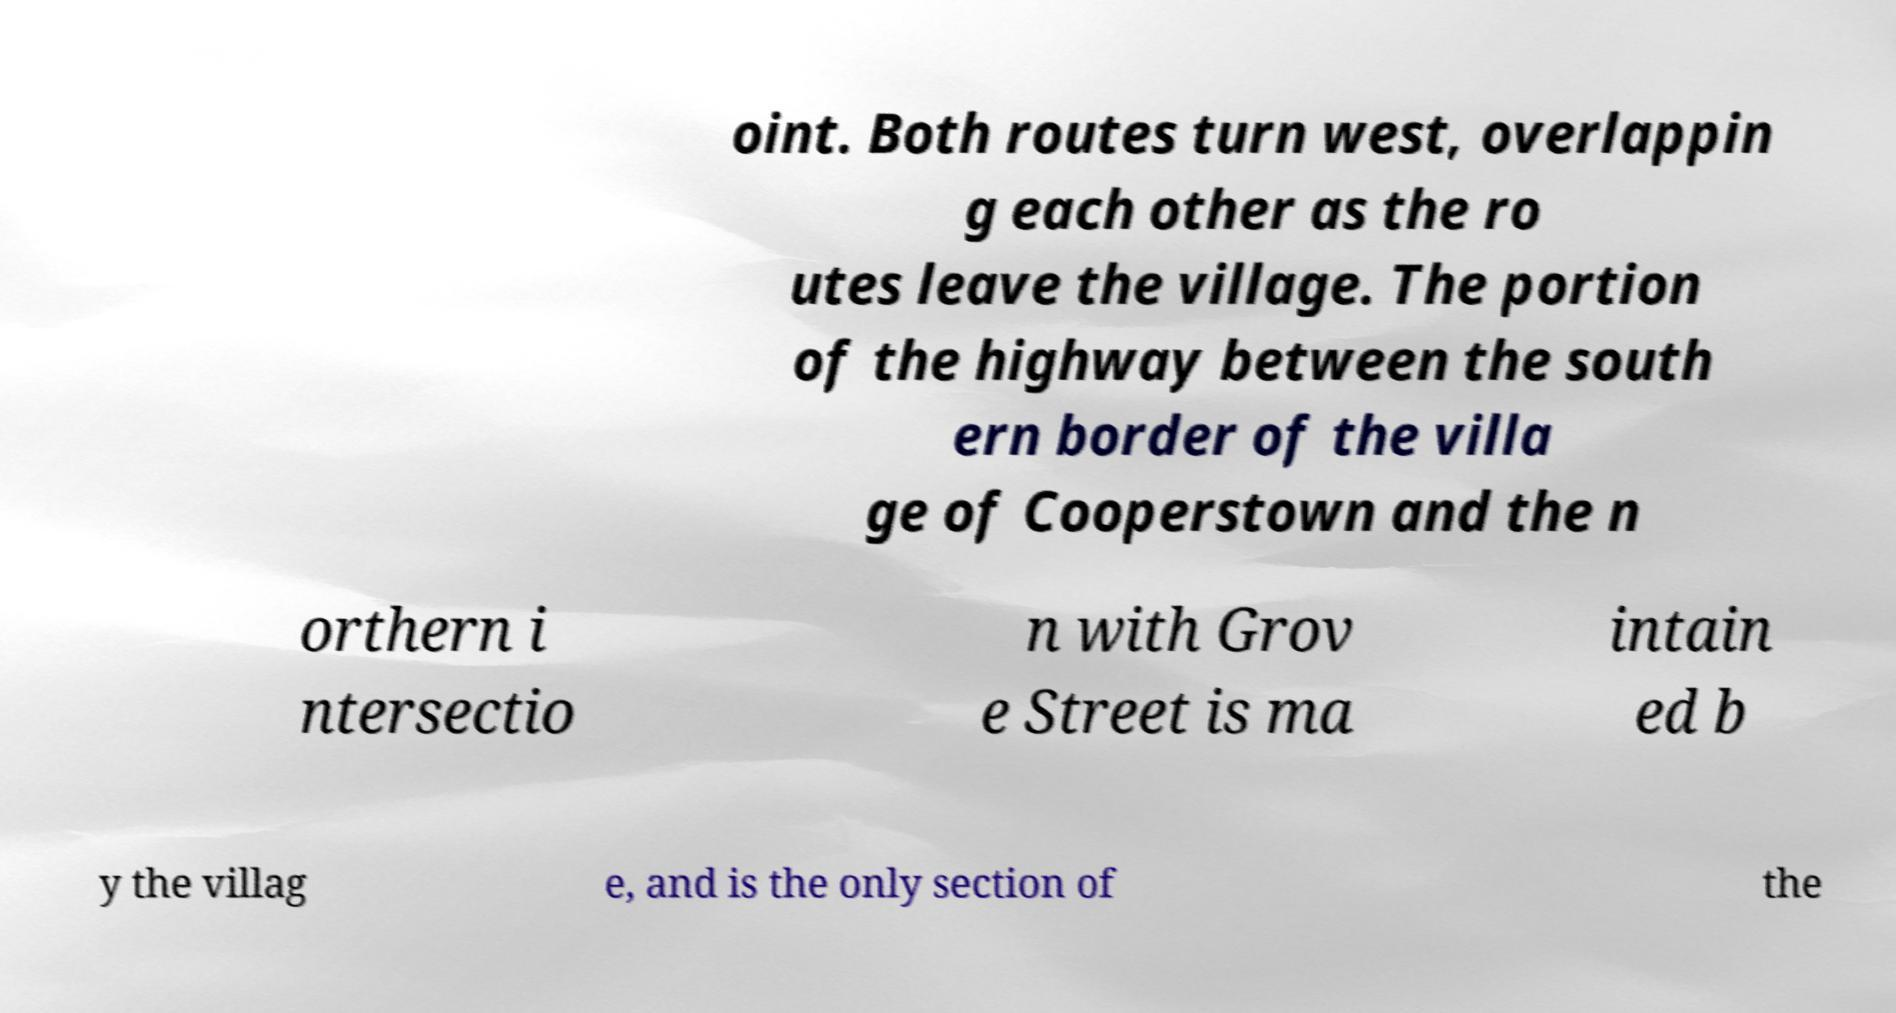Can you read and provide the text displayed in the image?This photo seems to have some interesting text. Can you extract and type it out for me? oint. Both routes turn west, overlappin g each other as the ro utes leave the village. The portion of the highway between the south ern border of the villa ge of Cooperstown and the n orthern i ntersectio n with Grov e Street is ma intain ed b y the villag e, and is the only section of the 